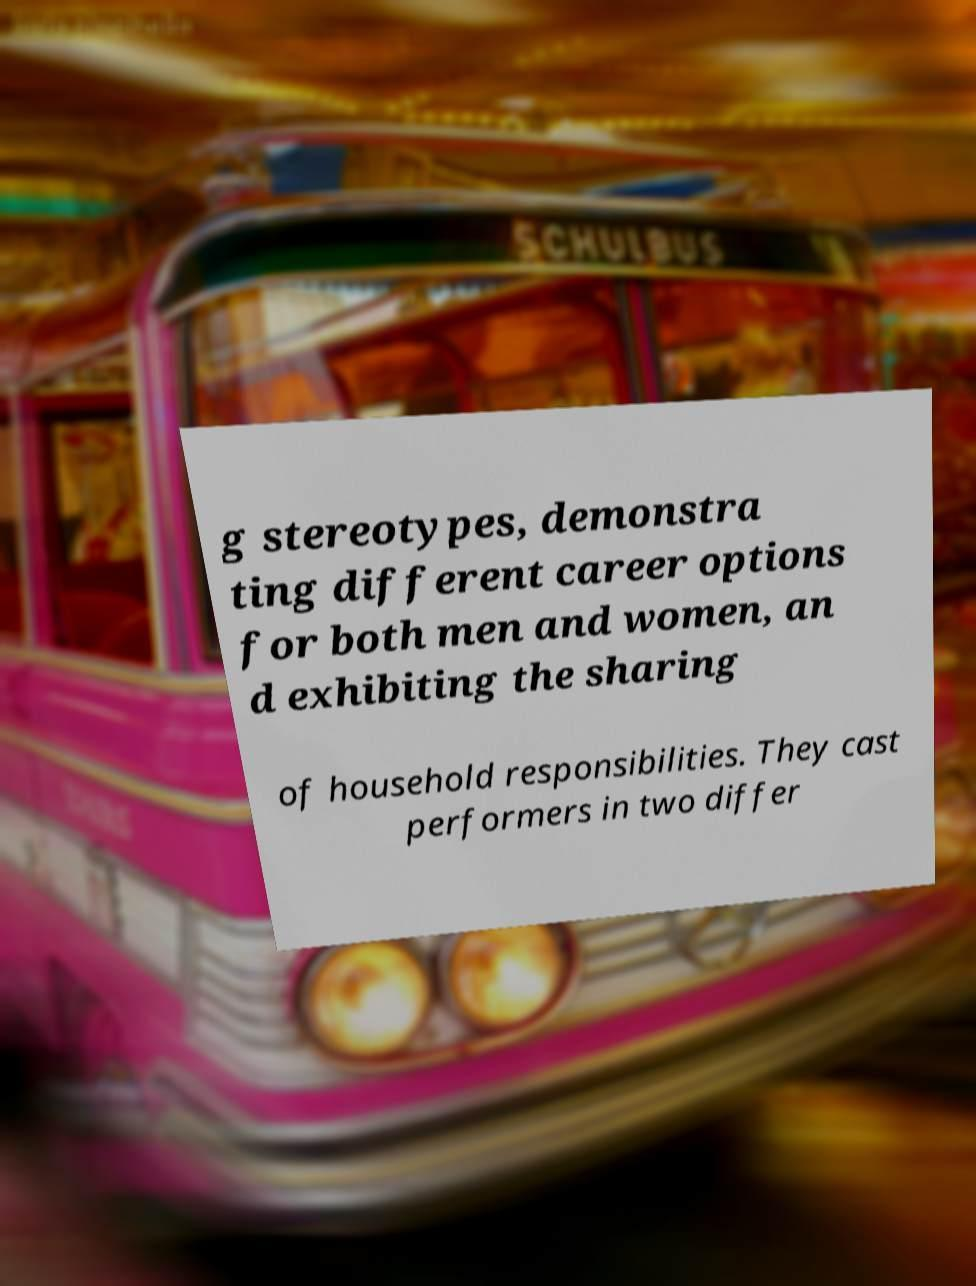What messages or text are displayed in this image? I need them in a readable, typed format. g stereotypes, demonstra ting different career options for both men and women, an d exhibiting the sharing of household responsibilities. They cast performers in two differ 